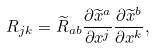<formula> <loc_0><loc_0><loc_500><loc_500>R _ { j k } = { \widetilde { R } } _ { a b } { \frac { \partial { \widetilde { x } } ^ { a } } { \partial x ^ { j } } } { \frac { \partial { \widetilde { x } } ^ { b } } { \partial x ^ { k } } } ,</formula> 